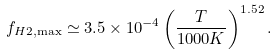<formula> <loc_0><loc_0><loc_500><loc_500>f _ { H 2 , \max } \simeq 3 . 5 \times 1 0 ^ { - 4 } \left ( \frac { T } { 1 0 0 0 K } \right ) ^ { 1 . 5 2 } .</formula> 